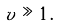Convert formula to latex. <formula><loc_0><loc_0><loc_500><loc_500>v \gg 1 \, .</formula> 